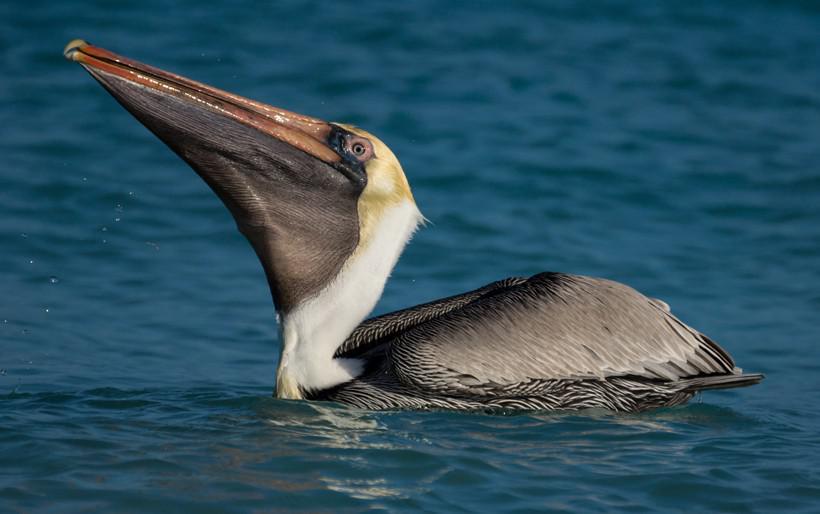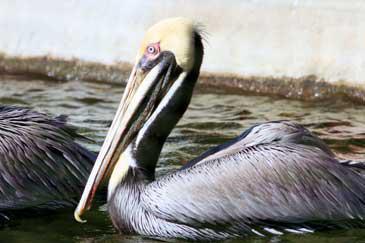The first image is the image on the left, the second image is the image on the right. Evaluate the accuracy of this statement regarding the images: "The left image features one pelican standing on a smooth rock, and the right image features one pelican swimming on water.". Is it true? Answer yes or no. No. 